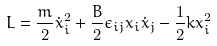Convert formula to latex. <formula><loc_0><loc_0><loc_500><loc_500>L = \frac { m } { 2 } \dot { x } ^ { 2 } _ { i } + \frac { B } { 2 } \epsilon _ { i j } x _ { i } \dot { x } _ { j } - \frac { 1 } { 2 } k x _ { i } ^ { 2 }</formula> 